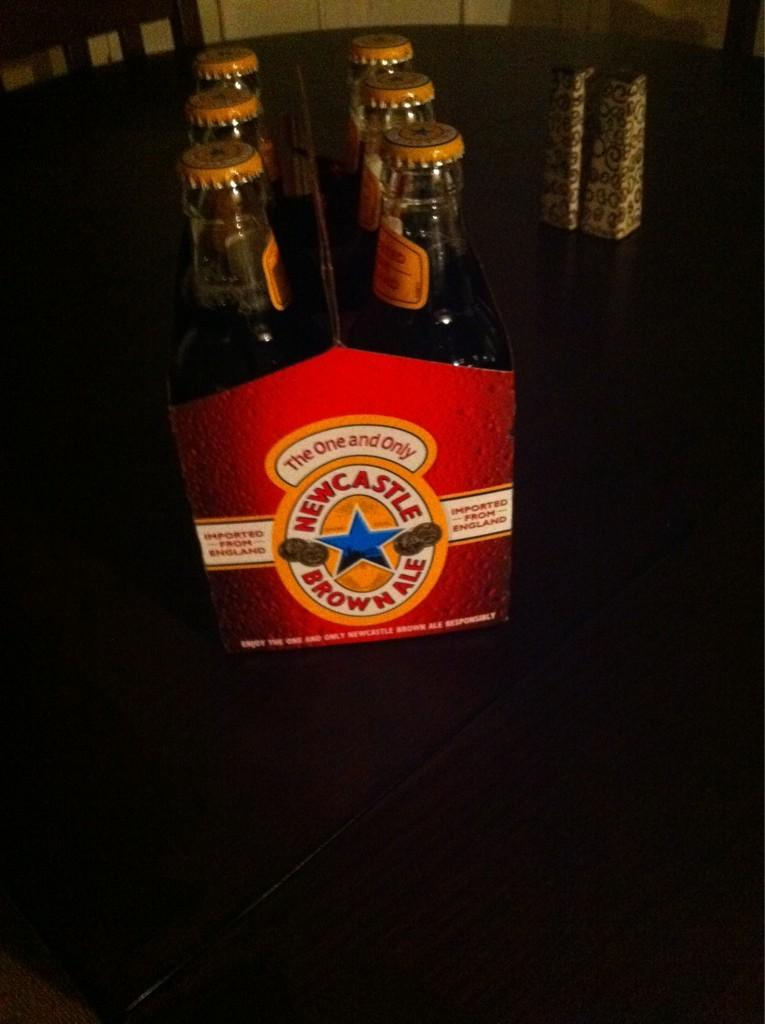<image>
Present a compact description of the photo's key features. A six pack of bottled Newcastle Brown Ale. 